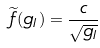Convert formula to latex. <formula><loc_0><loc_0><loc_500><loc_500>\widetilde { f } ( g _ { I } ) = \frac { c } { \sqrt { g _ { I } } }</formula> 